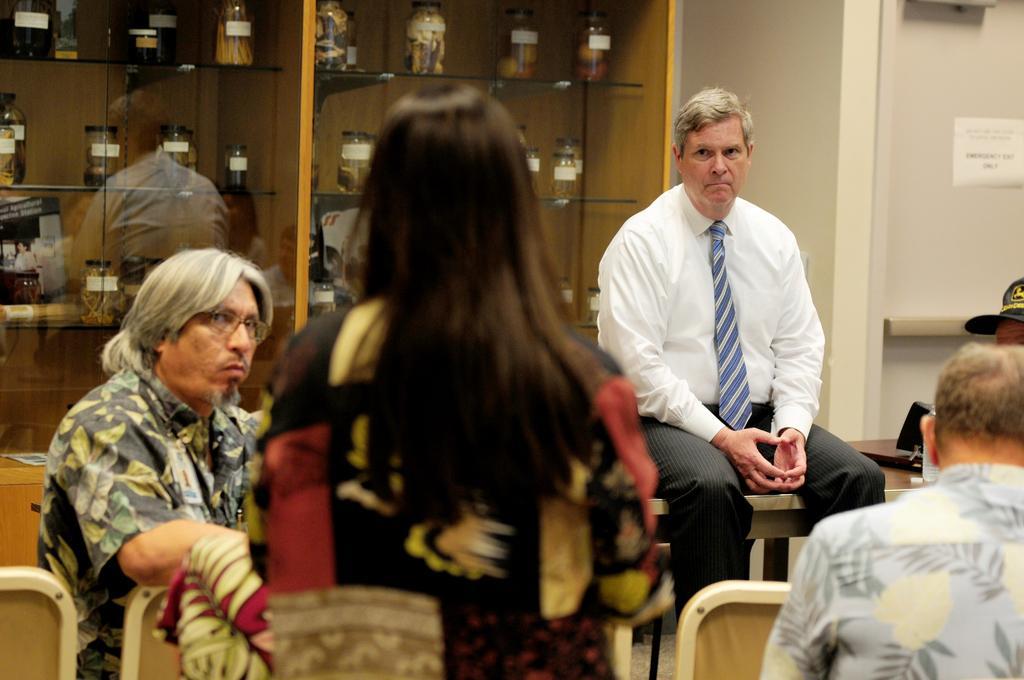Could you give a brief overview of what you see in this image? In this image ,we can see a person in the foreground ,and at the back some people are sitting ,and at the back we can see some bottles made of glass. 